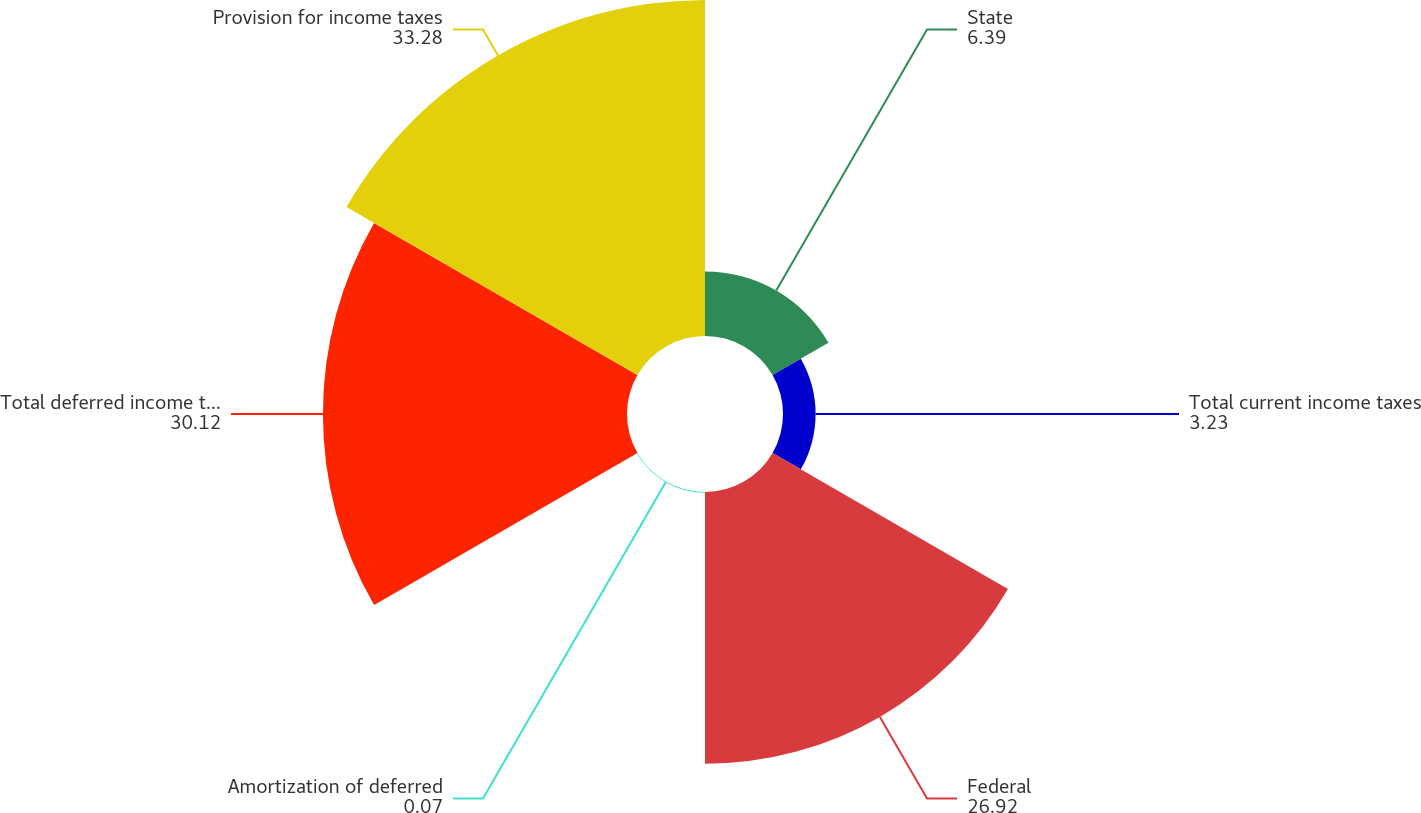<chart> <loc_0><loc_0><loc_500><loc_500><pie_chart><fcel>State<fcel>Total current income taxes<fcel>Federal<fcel>Amortization of deferred<fcel>Total deferred income taxes<fcel>Provision for income taxes<nl><fcel>6.39%<fcel>3.23%<fcel>26.92%<fcel>0.07%<fcel>30.12%<fcel>33.28%<nl></chart> 